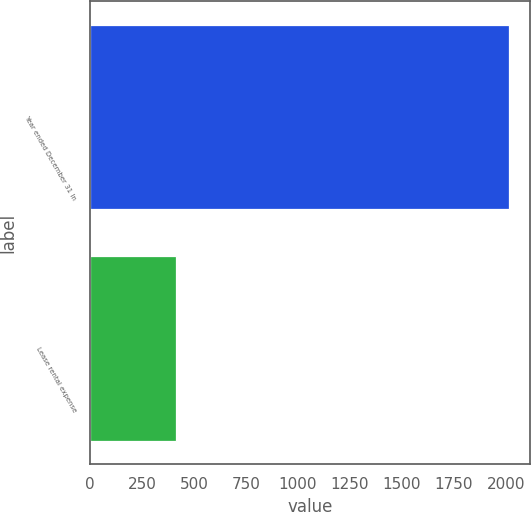Convert chart to OTSL. <chart><loc_0><loc_0><loc_500><loc_500><bar_chart><fcel>Year ended December 31 In<fcel>Lease rental expense<nl><fcel>2013<fcel>412<nl></chart> 